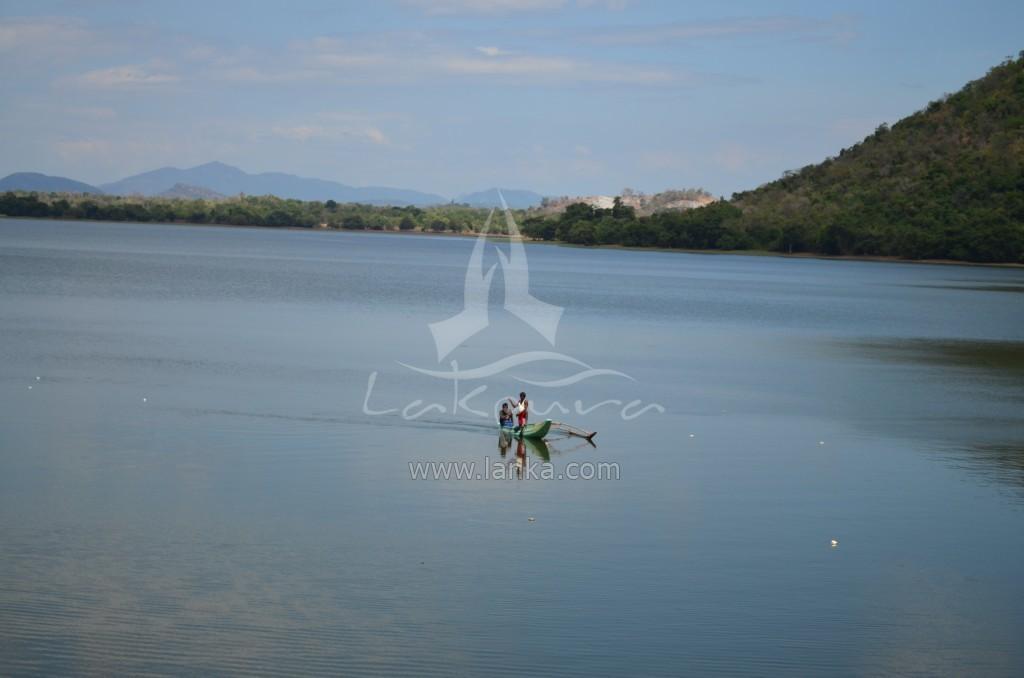Describe this image in one or two sentences. In the image there are two persons sitting in a boat in the middle of lake, in the background there are hills covered with trees all over the place and above its sky with clouds. 